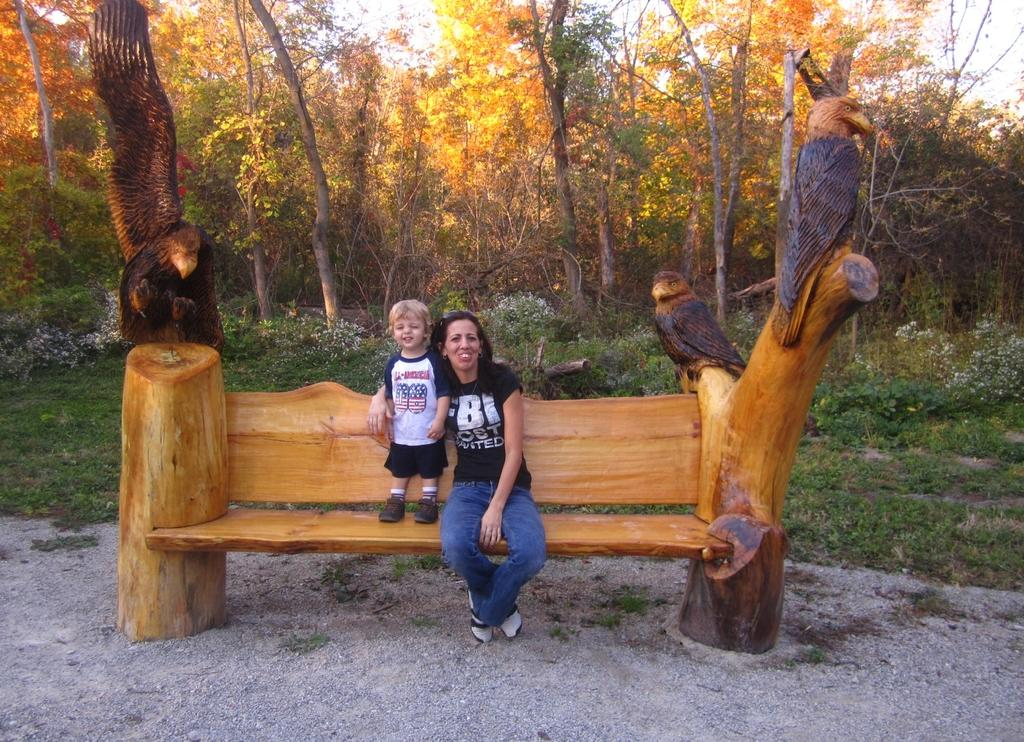What is the woman doing in the image? The woman is sitting on a bench in the image. Who is with the woman? There is a kid standing beside the woman in the image. What can be seen in the background of the image? Trees and plants are visible in the distance in the image. What is on the bench with the woman? There is a sculpture of birds on the bench in the image. What type of instrument is the farmer playing in the image? There is no farmer or instrument present in the image. 